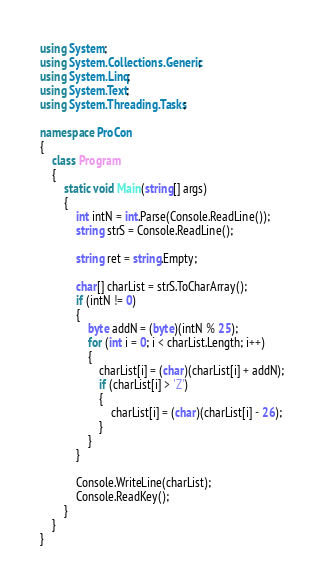Convert code to text. <code><loc_0><loc_0><loc_500><loc_500><_C#_>using System;
using System.Collections.Generic;
using System.Linq;
using System.Text;
using System.Threading.Tasks;

namespace ProCon
{
    class Program
    {
        static void Main(string[] args)
        {
            int intN = int.Parse(Console.ReadLine());
            string strS = Console.ReadLine();
            
            string ret = string.Empty;

            char[] charList = strS.ToCharArray();
            if (intN != 0)
            {
                byte addN = (byte)(intN % 25);
                for (int i = 0; i < charList.Length; i++)
                {
                    charList[i] = (char)(charList[i] + addN);
                    if (charList[i] > 'Z')
                    {
                        charList[i] = (char)(charList[i] - 26);
                    }
                }
            }

            Console.WriteLine(charList);
            Console.ReadKey();
        }
    }
}
</code> 